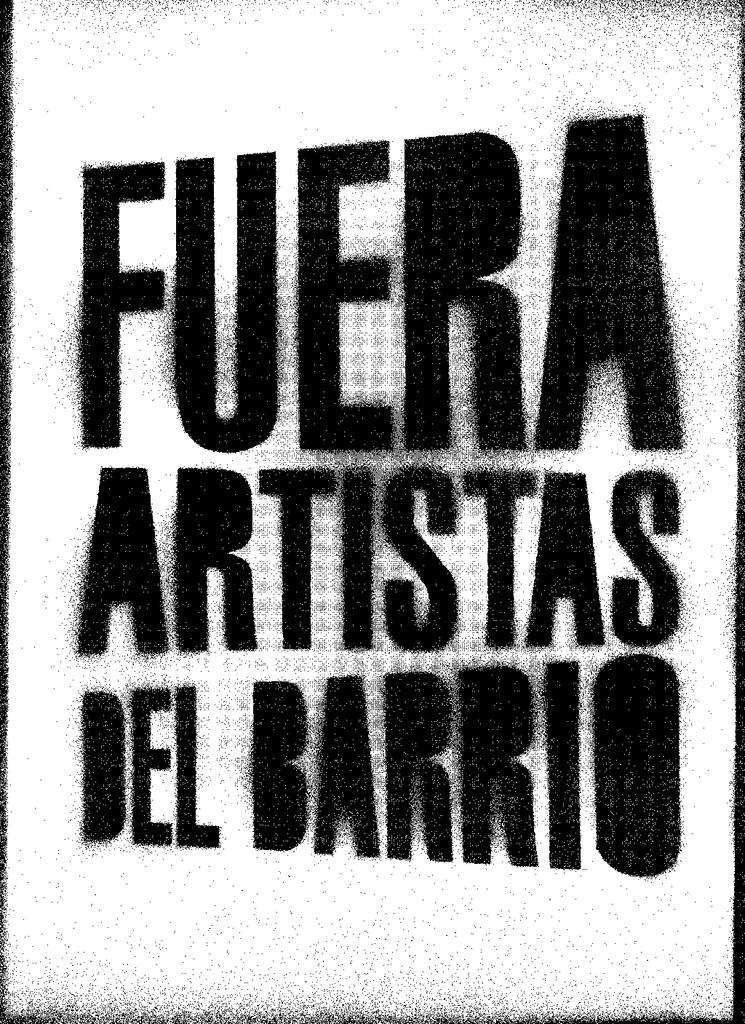Provide a one-sentence caption for the provided image. A spray painted poster reads Fuera Artistas Del Barrio. 